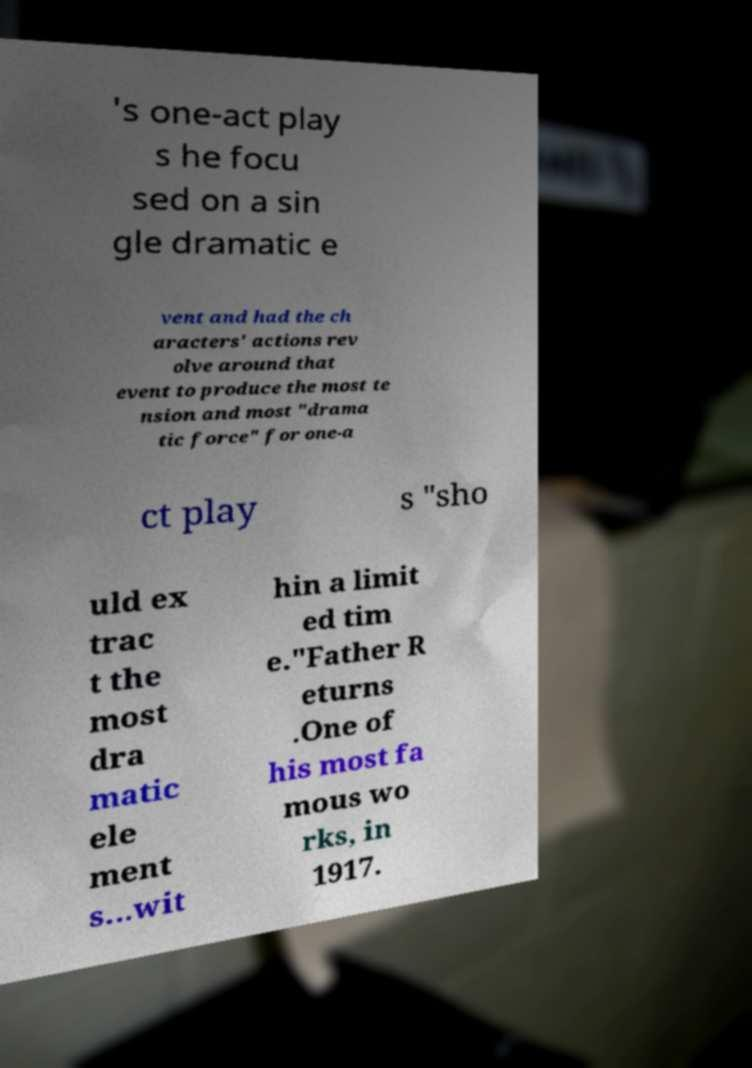I need the written content from this picture converted into text. Can you do that? 's one-act play s he focu sed on a sin gle dramatic e vent and had the ch aracters' actions rev olve around that event to produce the most te nsion and most "drama tic force" for one-a ct play s "sho uld ex trac t the most dra matic ele ment s...wit hin a limit ed tim e."Father R eturns .One of his most fa mous wo rks, in 1917. 